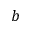<formula> <loc_0><loc_0><loc_500><loc_500>b</formula> 